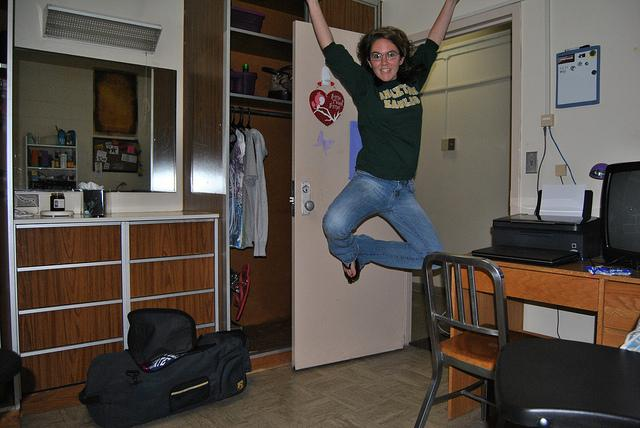Where is the woman jumping? Please explain your reasoning. dorm room. The room is personalized and everything is in a small area 